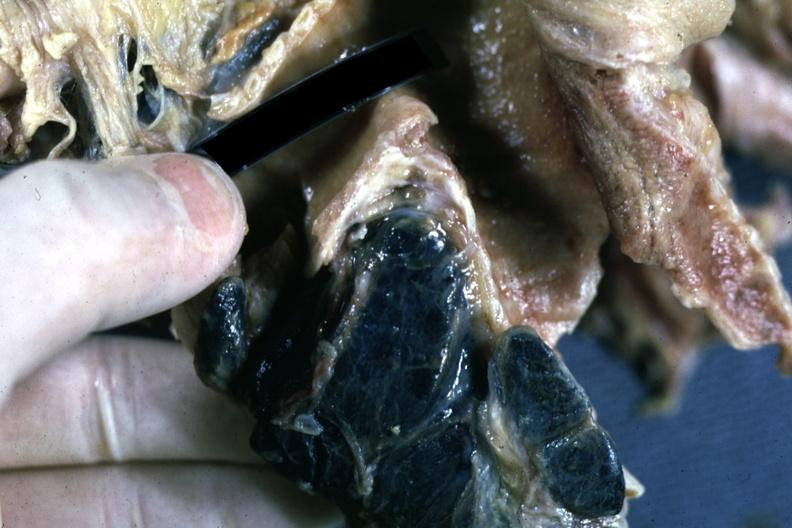what are filled with black pigment?
Answer the question using a single word or phrase. Carinal nodes shown close-up nodes 